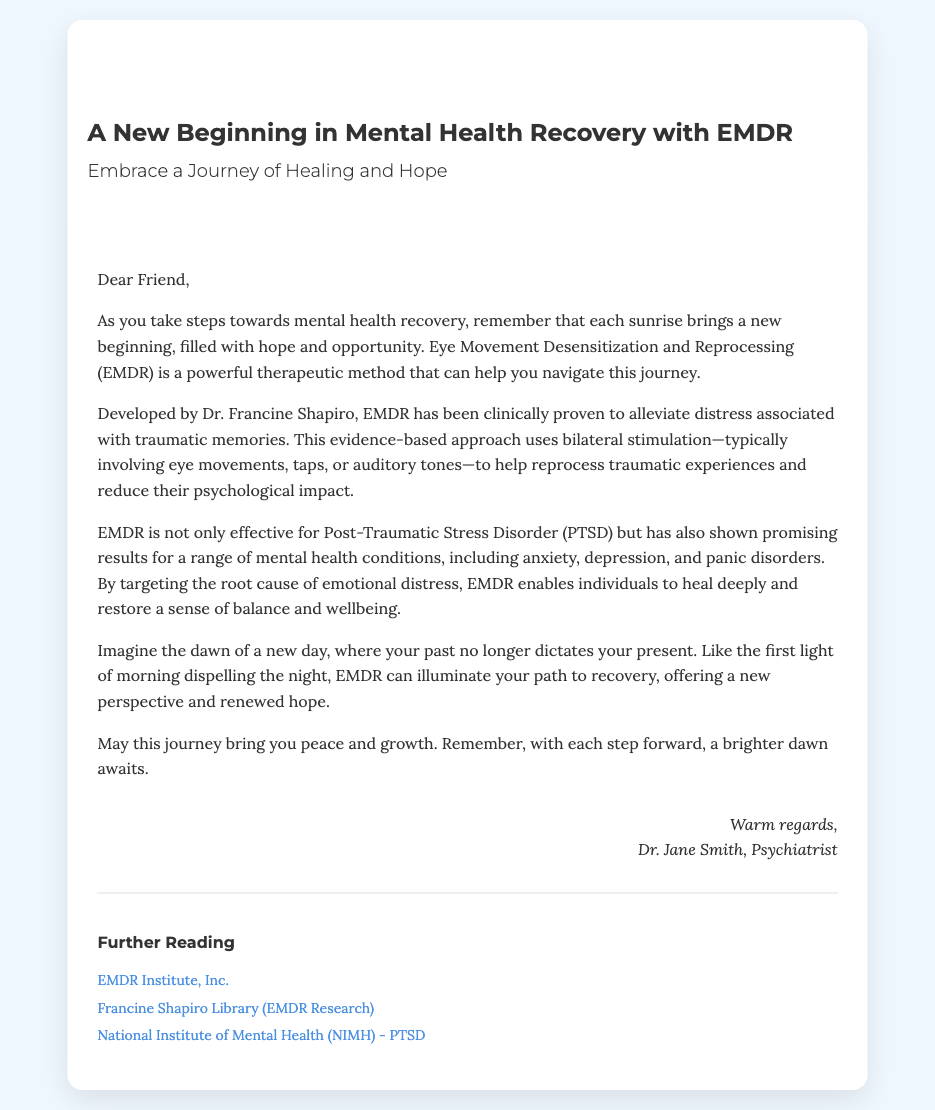What is the title of the card? The title of the card is displayed prominently at the top, indicating the theme of the card.
Answer: A New Beginning in Mental Health Recovery with EMDR Who developed EMDR? The document mentions the creator of EMDR, providing important context for the therapeutic approach.
Answer: Dr. Francine Shapiro What conditions is EMDR effective for? The card lists several specific mental health conditions EMDR is helpful for, highlighting its versatility as a treatment.
Answer: PTSD, anxiety, depression, panic disorders What imagery is used to symbolize hope? The card uses specific imagery to convey its message of new beginnings and renewal in the context of recovery.
Answer: Sunrise What is the signature in the card? The signature provides a personal touch, indicating who the card is from, which adds credibility and warmth to the message.
Answer: Dr. Jane Smith, Psychiatrist What is the background color of the card? The background color helps to create an inviting atmosphere for the card, aligning with the overall theme of hope and recovery.
Answer: Light blue (#f0f8ff) What type of card is this document? The document type helps to define its purpose and how it is intended to be used or received by the recipient.
Answer: Greeting card What is the main message for the recipient? The document aims to convey a specific sentiment of encouragement and hope through its wording and imagery.
Answer: Embrace a Journey of Healing and Hope 